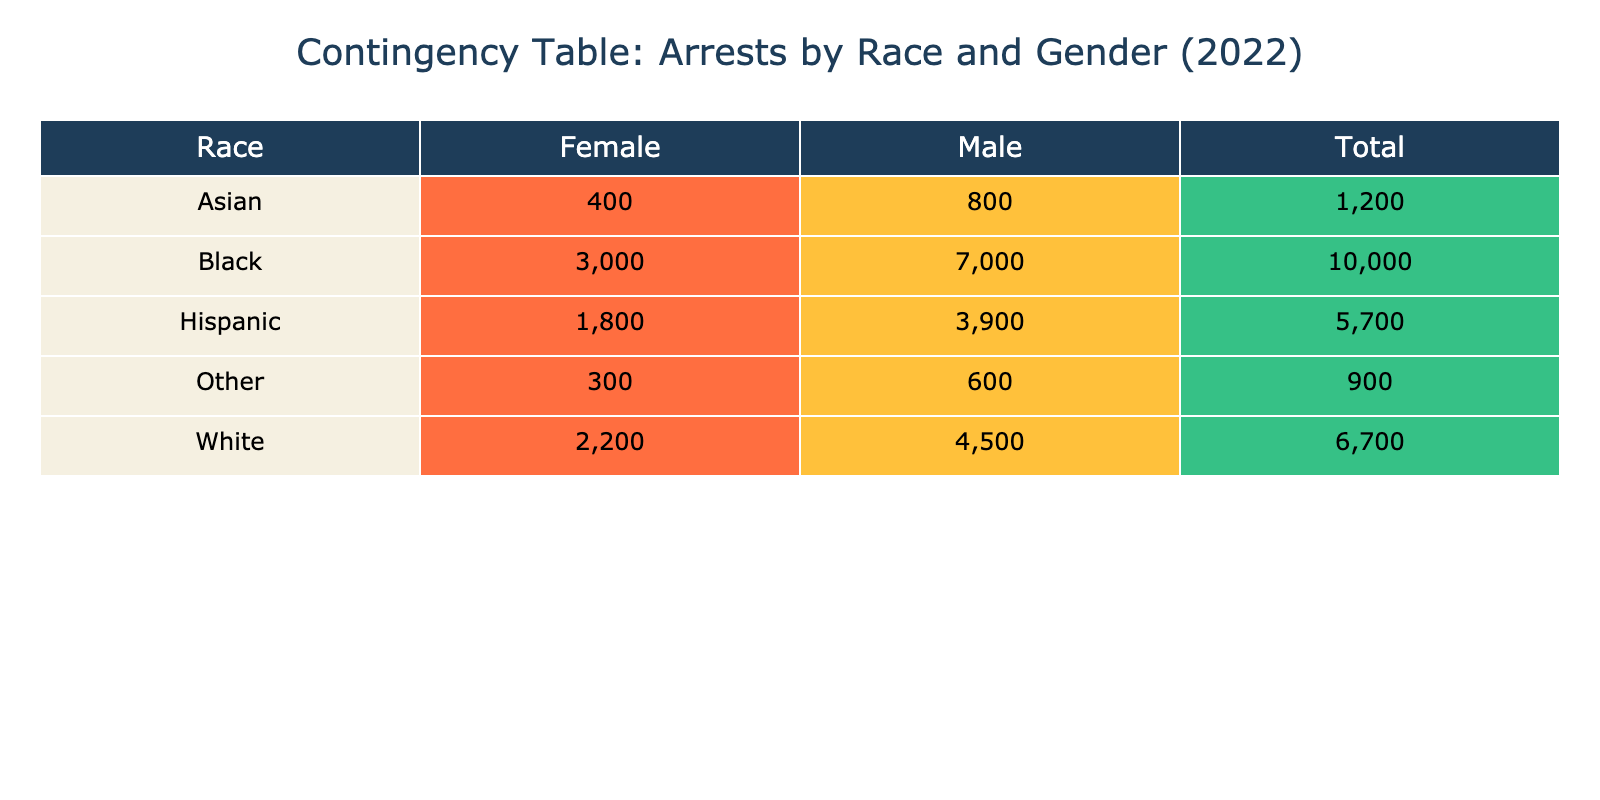What is the total number of arrests for White females? From the table, we can directly see that the number of arrests for White females is listed as 2200.
Answer: 2200 What is the number of arrests for Black males compared to Hispanic females? The number of arrests for Black males is 7000, and for Hispanic females, it is 1800. Comparing these, Black males have 7000 arrests while Hispanic females have 1800 arrests.
Answer: Black males have more arrests What is the total number of arrests recorded for males across all races? We calculate the total number of arrests for males by adding the number of arrests for each male category: White (4500) + Black (7000) + Hispanic (3900) + Asian (800) + Other (600) = 4500 + 7000 + 3900 + 800 + 600 = 16800.
Answer: 16800 Is the number of arrests for Asian females greater than the number of arrests for Black females? The table shows that arrests for Asian females are 400, while arrests for Black females are 3000. Since 400 is less than 3000, the statement is false.
Answer: No What percentage of the total arrests were made up by Hispanic males? First, we need to find the total number of arrests from the table, which is 4500 (White males) + 2200 (White females) + 7000 (Black males) + 3000 (Black females) + 3900 (Hispanic males) + 1800 (Hispanic females) + 800 (Asian males) + 400 (Asian females) + 600 (Other males) + 300 (Other females) = 18600. Now, Hispanic males have 3900 arrests. The percentage is calculated as (3900/18600) * 100 ≈ 20.97%.
Answer: Approximately 20.97% What is the combined total number of arrests for individuals classified as 'Other'? The total for 'Other' consists of arrests for Other males (600) and Other females (300). Therefore, the combined total is 600 + 300 = 900.
Answer: 900 